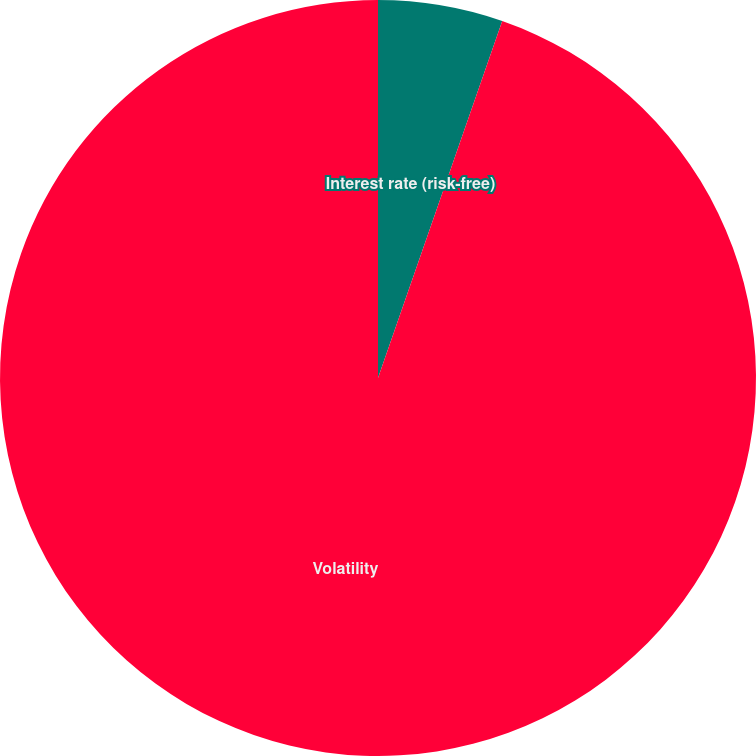Convert chart to OTSL. <chart><loc_0><loc_0><loc_500><loc_500><pie_chart><fcel>Interest rate (risk-free)<fcel>Volatility<nl><fcel>5.33%<fcel>94.67%<nl></chart> 